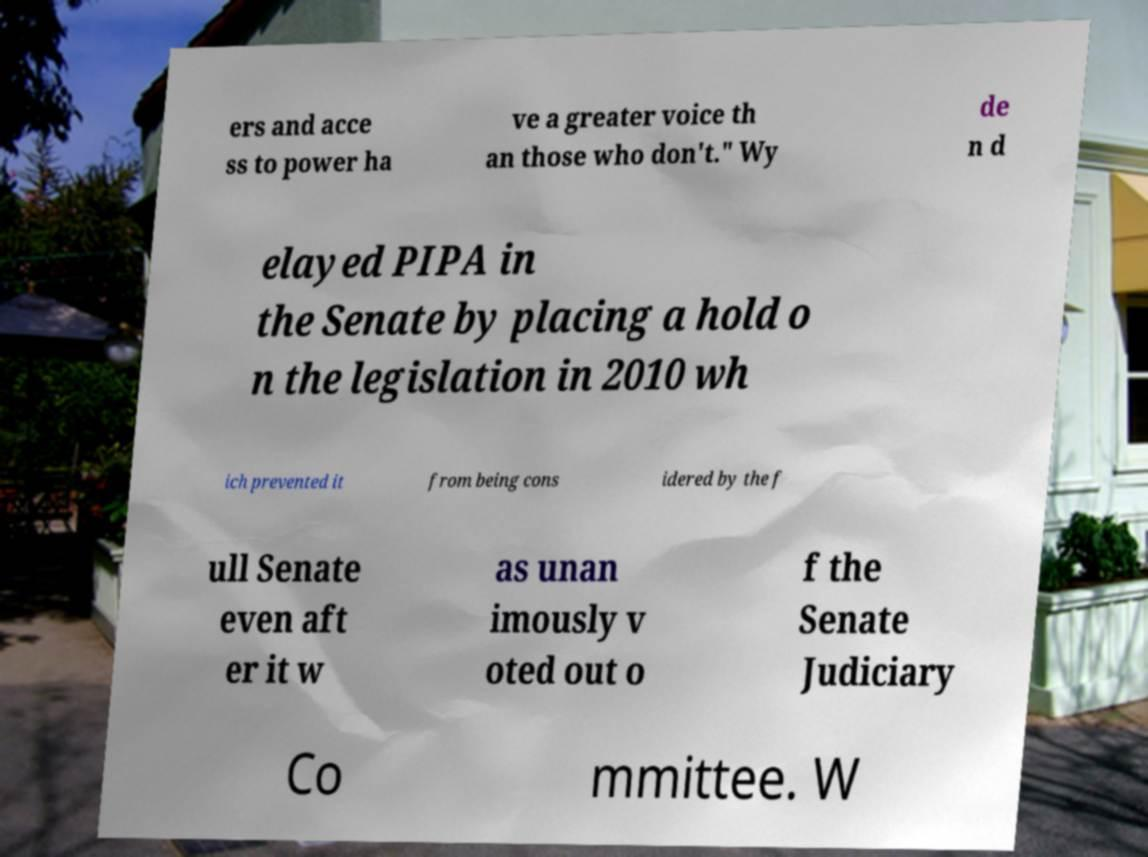Can you accurately transcribe the text from the provided image for me? ers and acce ss to power ha ve a greater voice th an those who don't." Wy de n d elayed PIPA in the Senate by placing a hold o n the legislation in 2010 wh ich prevented it from being cons idered by the f ull Senate even aft er it w as unan imously v oted out o f the Senate Judiciary Co mmittee. W 